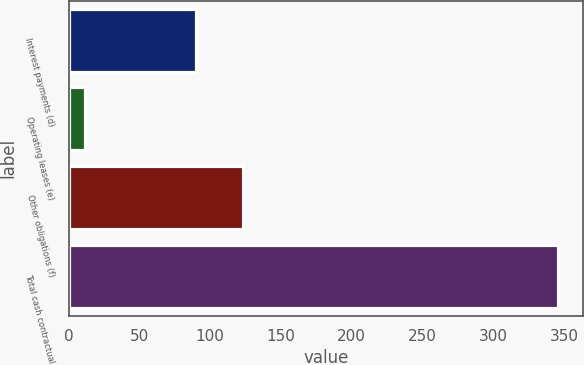Convert chart to OTSL. <chart><loc_0><loc_0><loc_500><loc_500><bar_chart><fcel>Interest payments (d)<fcel>Operating leases (e)<fcel>Other obligations (f)<fcel>Total cash contractual<nl><fcel>90<fcel>12<fcel>123.4<fcel>346<nl></chart> 